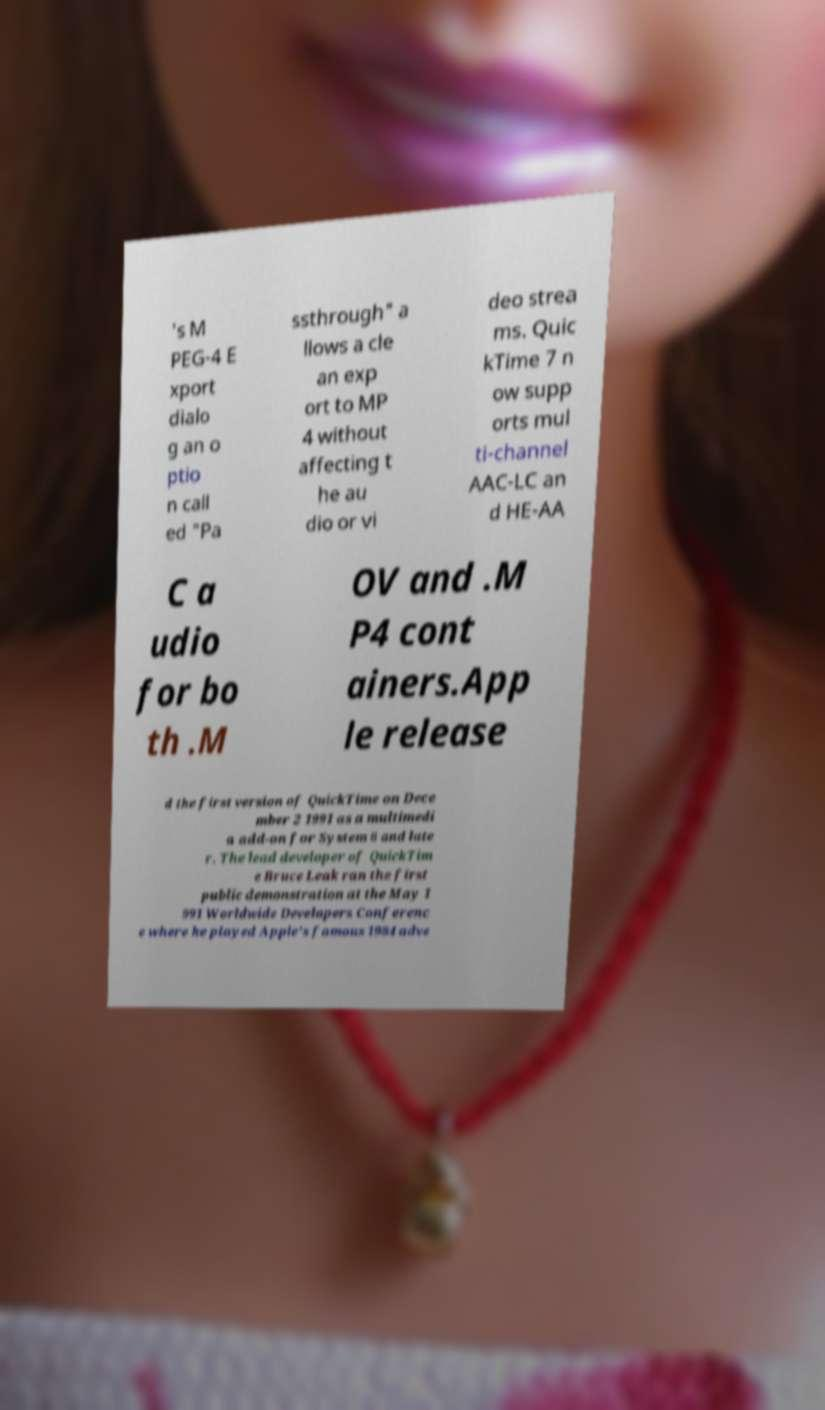There's text embedded in this image that I need extracted. Can you transcribe it verbatim? 's M PEG-4 E xport dialo g an o ptio n call ed "Pa ssthrough" a llows a cle an exp ort to MP 4 without affecting t he au dio or vi deo strea ms. Quic kTime 7 n ow supp orts mul ti-channel AAC-LC an d HE-AA C a udio for bo th .M OV and .M P4 cont ainers.App le release d the first version of QuickTime on Dece mber 2 1991 as a multimedi a add-on for System 6 and late r. The lead developer of QuickTim e Bruce Leak ran the first public demonstration at the May 1 991 Worldwide Developers Conferenc e where he played Apple's famous 1984 adve 